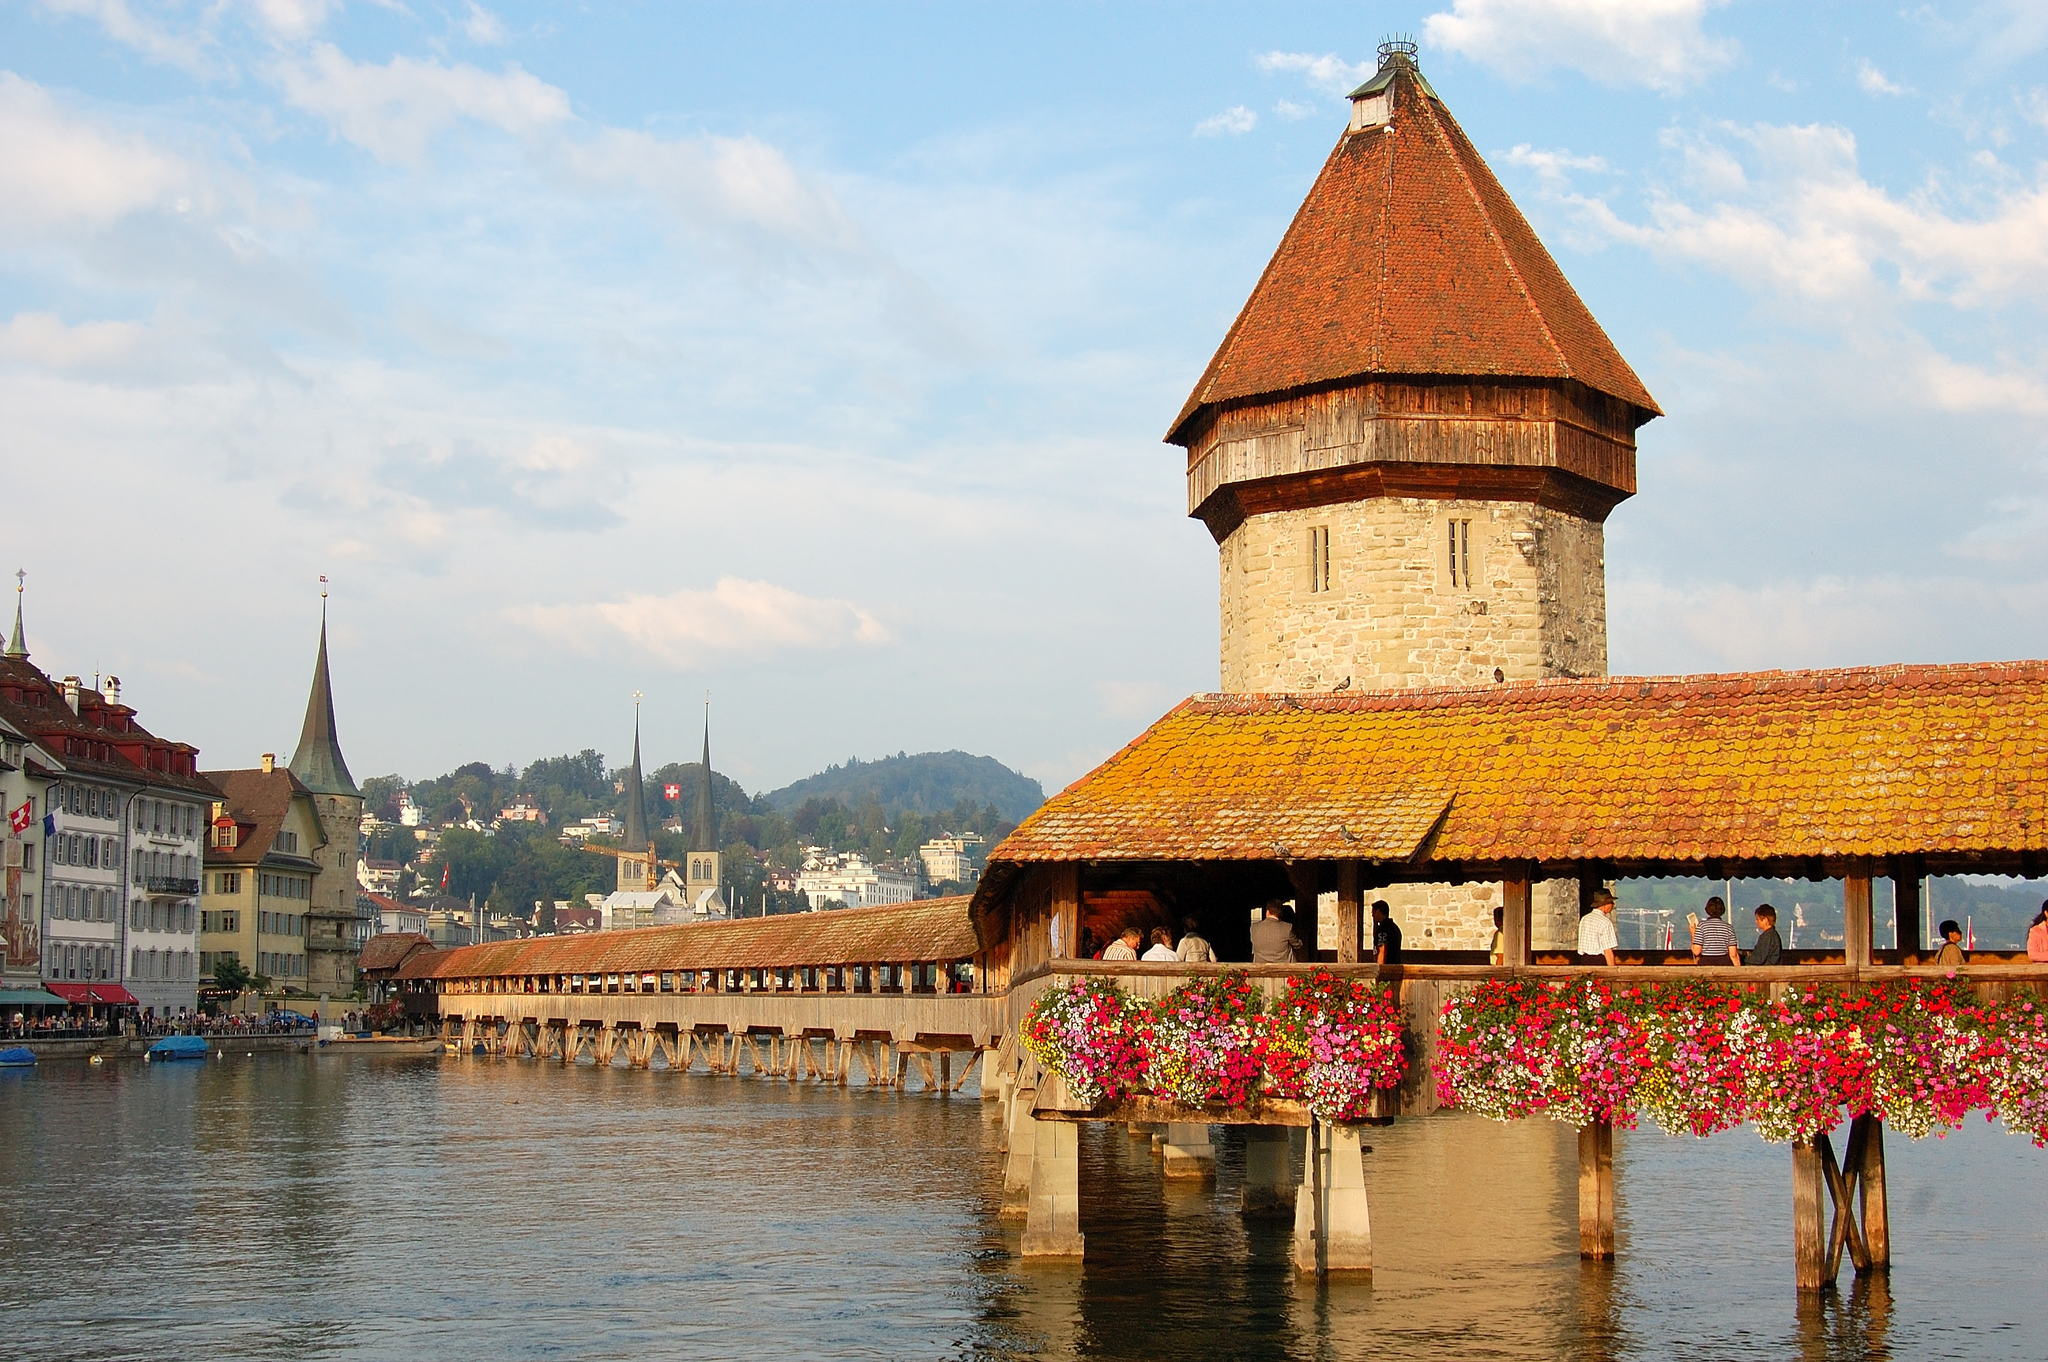Imagine a day in the life of a medieval merchant crossing this bridge. A medieval merchant crossing Chapel Bridge might start his day early, scurrying across the wooden planks with a cart full of goods – spices, textiles, and handcrafted wares. The morning air is brisk, the river’s mist swirling around as he greets fellow traders. He exchanges news and pleasantries before setting up his stall in the bustling market area. Throughout the day, he haggles, trades, and forms alliances, the bridge always in his sight. As the day wanes, he once again crosses the bridge, coins jingling in his pouch, a sense of accomplishment as the city’s lights begin to twinkle, reflecting off the Reuss River. 